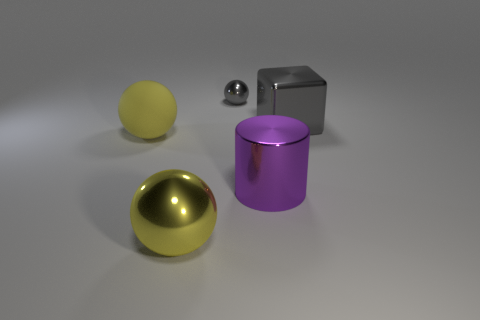Add 3 large yellow metallic cubes. How many objects exist? 8 Subtract all large yellow balls. How many balls are left? 1 Subtract all gray spheres. How many spheres are left? 2 Subtract all cubes. How many objects are left? 4 Subtract all tiny red metallic things. Subtract all small gray metallic balls. How many objects are left? 4 Add 5 gray metal blocks. How many gray metal blocks are left? 6 Add 5 purple shiny cylinders. How many purple shiny cylinders exist? 6 Subtract 0 yellow cubes. How many objects are left? 5 Subtract 2 balls. How many balls are left? 1 Subtract all blue spheres. Subtract all red cylinders. How many spheres are left? 3 